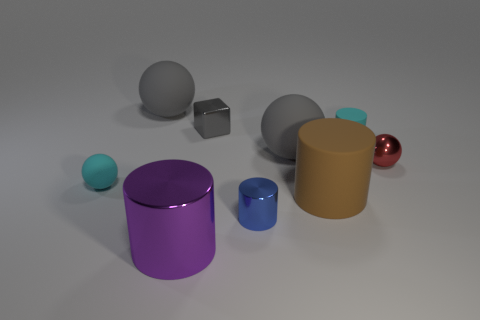Subtract 1 cylinders. How many cylinders are left? 3 Subtract all cylinders. How many objects are left? 5 Subtract 0 cyan cubes. How many objects are left? 9 Subtract all big spheres. Subtract all cyan objects. How many objects are left? 5 Add 6 small cyan cylinders. How many small cyan cylinders are left? 7 Add 8 tiny cyan objects. How many tiny cyan objects exist? 10 